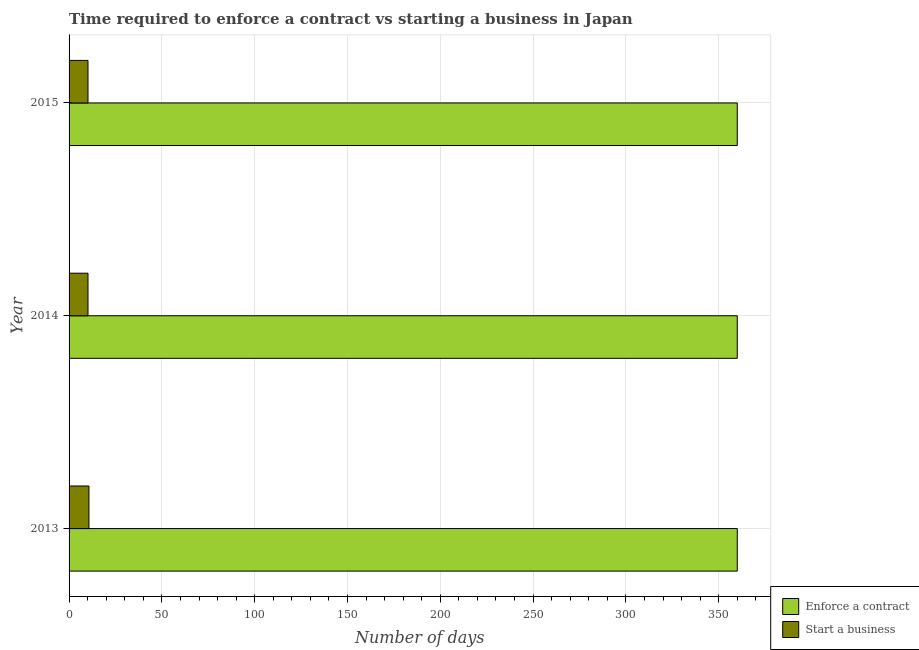Are the number of bars per tick equal to the number of legend labels?
Offer a very short reply. Yes. Are the number of bars on each tick of the Y-axis equal?
Your answer should be very brief. Yes. How many bars are there on the 1st tick from the bottom?
Keep it short and to the point. 2. What is the label of the 2nd group of bars from the top?
Your answer should be very brief. 2014. Across all years, what is the maximum number of days to enforece a contract?
Make the answer very short. 360. In which year was the number of days to enforece a contract minimum?
Your answer should be very brief. 2013. What is the total number of days to start a business in the graph?
Provide a short and direct response. 31.1. What is the difference between the number of days to enforece a contract in 2014 and the number of days to start a business in 2013?
Give a very brief answer. 349.3. What is the average number of days to start a business per year?
Offer a terse response. 10.37. In the year 2013, what is the difference between the number of days to enforece a contract and number of days to start a business?
Keep it short and to the point. 349.3. What is the ratio of the number of days to enforece a contract in 2013 to that in 2015?
Offer a terse response. 1. Is the difference between the number of days to start a business in 2013 and 2014 greater than the difference between the number of days to enforece a contract in 2013 and 2014?
Keep it short and to the point. Yes. What is the difference between the highest and the second highest number of days to start a business?
Your response must be concise. 0.5. What is the difference between the highest and the lowest number of days to enforece a contract?
Offer a very short reply. 0. In how many years, is the number of days to enforece a contract greater than the average number of days to enforece a contract taken over all years?
Offer a very short reply. 0. Is the sum of the number of days to start a business in 2014 and 2015 greater than the maximum number of days to enforece a contract across all years?
Your answer should be compact. No. What does the 1st bar from the top in 2014 represents?
Ensure brevity in your answer.  Start a business. What does the 2nd bar from the bottom in 2013 represents?
Offer a very short reply. Start a business. How many years are there in the graph?
Offer a terse response. 3. Does the graph contain any zero values?
Keep it short and to the point. No. Where does the legend appear in the graph?
Keep it short and to the point. Bottom right. What is the title of the graph?
Your answer should be very brief. Time required to enforce a contract vs starting a business in Japan. Does "Grants" appear as one of the legend labels in the graph?
Keep it short and to the point. No. What is the label or title of the X-axis?
Provide a succinct answer. Number of days. What is the label or title of the Y-axis?
Ensure brevity in your answer.  Year. What is the Number of days in Enforce a contract in 2013?
Give a very brief answer. 360. What is the Number of days in Start a business in 2013?
Make the answer very short. 10.7. What is the Number of days of Enforce a contract in 2014?
Offer a very short reply. 360. What is the Number of days of Enforce a contract in 2015?
Ensure brevity in your answer.  360. What is the Number of days in Start a business in 2015?
Offer a terse response. 10.2. Across all years, what is the maximum Number of days of Enforce a contract?
Give a very brief answer. 360. Across all years, what is the maximum Number of days of Start a business?
Make the answer very short. 10.7. Across all years, what is the minimum Number of days in Enforce a contract?
Offer a terse response. 360. What is the total Number of days in Enforce a contract in the graph?
Provide a succinct answer. 1080. What is the total Number of days of Start a business in the graph?
Make the answer very short. 31.1. What is the difference between the Number of days in Start a business in 2013 and that in 2014?
Your answer should be compact. 0.5. What is the difference between the Number of days of Enforce a contract in 2013 and that in 2015?
Give a very brief answer. 0. What is the difference between the Number of days of Enforce a contract in 2013 and the Number of days of Start a business in 2014?
Your answer should be very brief. 349.8. What is the difference between the Number of days of Enforce a contract in 2013 and the Number of days of Start a business in 2015?
Provide a succinct answer. 349.8. What is the difference between the Number of days in Enforce a contract in 2014 and the Number of days in Start a business in 2015?
Your response must be concise. 349.8. What is the average Number of days of Enforce a contract per year?
Your response must be concise. 360. What is the average Number of days of Start a business per year?
Your answer should be very brief. 10.37. In the year 2013, what is the difference between the Number of days in Enforce a contract and Number of days in Start a business?
Keep it short and to the point. 349.3. In the year 2014, what is the difference between the Number of days in Enforce a contract and Number of days in Start a business?
Keep it short and to the point. 349.8. In the year 2015, what is the difference between the Number of days in Enforce a contract and Number of days in Start a business?
Offer a very short reply. 349.8. What is the ratio of the Number of days of Enforce a contract in 2013 to that in 2014?
Ensure brevity in your answer.  1. What is the ratio of the Number of days in Start a business in 2013 to that in 2014?
Offer a terse response. 1.05. What is the ratio of the Number of days in Start a business in 2013 to that in 2015?
Offer a terse response. 1.05. What is the ratio of the Number of days in Enforce a contract in 2014 to that in 2015?
Keep it short and to the point. 1. What is the difference between the highest and the second highest Number of days in Enforce a contract?
Give a very brief answer. 0. What is the difference between the highest and the second highest Number of days of Start a business?
Provide a succinct answer. 0.5. What is the difference between the highest and the lowest Number of days of Start a business?
Give a very brief answer. 0.5. 